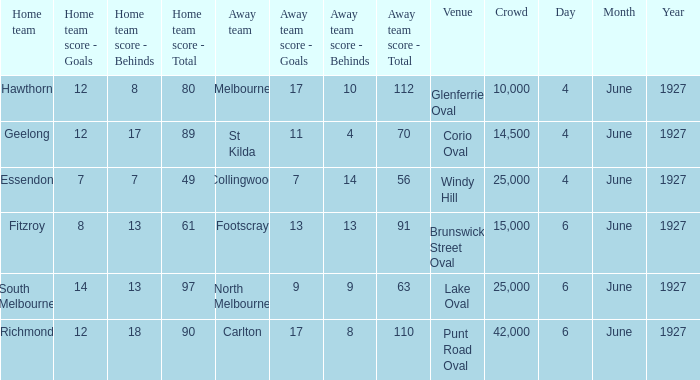How many people in the crowd with north melbourne as an away team? 25000.0. 